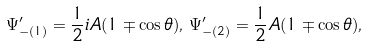Convert formula to latex. <formula><loc_0><loc_0><loc_500><loc_500>\Psi ^ { \prime } _ { - ( 1 ) } = \frac { 1 } { 2 } i A ( 1 \mp \cos { \theta } ) , \, \Psi ^ { \prime } _ { - ( 2 ) } = \frac { 1 } { 2 } A ( 1 \mp \cos { \theta } ) ,</formula> 